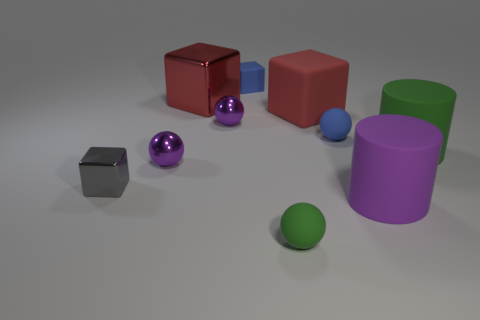Subtract all red metal cubes. How many cubes are left? 3 Subtract all gray blocks. How many purple balls are left? 2 Subtract all green spheres. How many spheres are left? 3 Subtract 2 balls. How many balls are left? 2 Subtract all balls. How many objects are left? 6 Subtract all yellow balls. Subtract all gray cylinders. How many balls are left? 4 Subtract 0 blue cylinders. How many objects are left? 10 Subtract all purple metal things. Subtract all large red cubes. How many objects are left? 6 Add 4 blue matte spheres. How many blue matte spheres are left? 5 Add 7 matte cylinders. How many matte cylinders exist? 9 